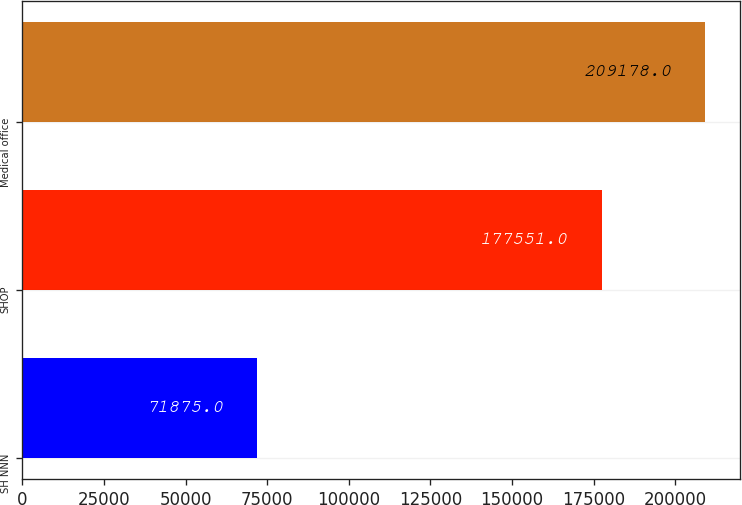Convert chart. <chart><loc_0><loc_0><loc_500><loc_500><bar_chart><fcel>SH NNN<fcel>SHOP<fcel>Medical office<nl><fcel>71875<fcel>177551<fcel>209178<nl></chart> 